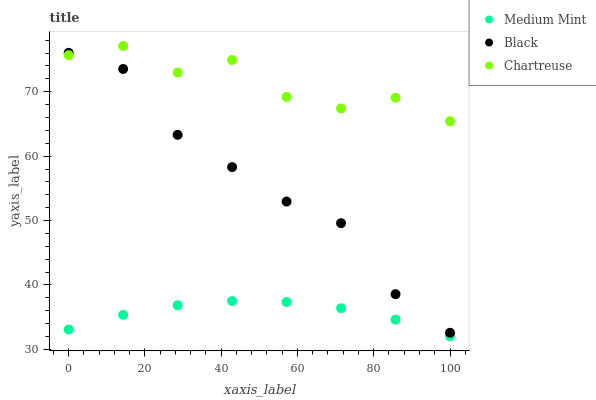Does Medium Mint have the minimum area under the curve?
Answer yes or no. Yes. Does Chartreuse have the maximum area under the curve?
Answer yes or no. Yes. Does Black have the minimum area under the curve?
Answer yes or no. No. Does Black have the maximum area under the curve?
Answer yes or no. No. Is Medium Mint the smoothest?
Answer yes or no. Yes. Is Chartreuse the roughest?
Answer yes or no. Yes. Is Black the smoothest?
Answer yes or no. No. Is Black the roughest?
Answer yes or no. No. Does Medium Mint have the lowest value?
Answer yes or no. Yes. Does Black have the lowest value?
Answer yes or no. No. Does Chartreuse have the highest value?
Answer yes or no. Yes. Does Black have the highest value?
Answer yes or no. No. Is Medium Mint less than Black?
Answer yes or no. Yes. Is Chartreuse greater than Medium Mint?
Answer yes or no. Yes. Does Chartreuse intersect Black?
Answer yes or no. Yes. Is Chartreuse less than Black?
Answer yes or no. No. Is Chartreuse greater than Black?
Answer yes or no. No. Does Medium Mint intersect Black?
Answer yes or no. No. 